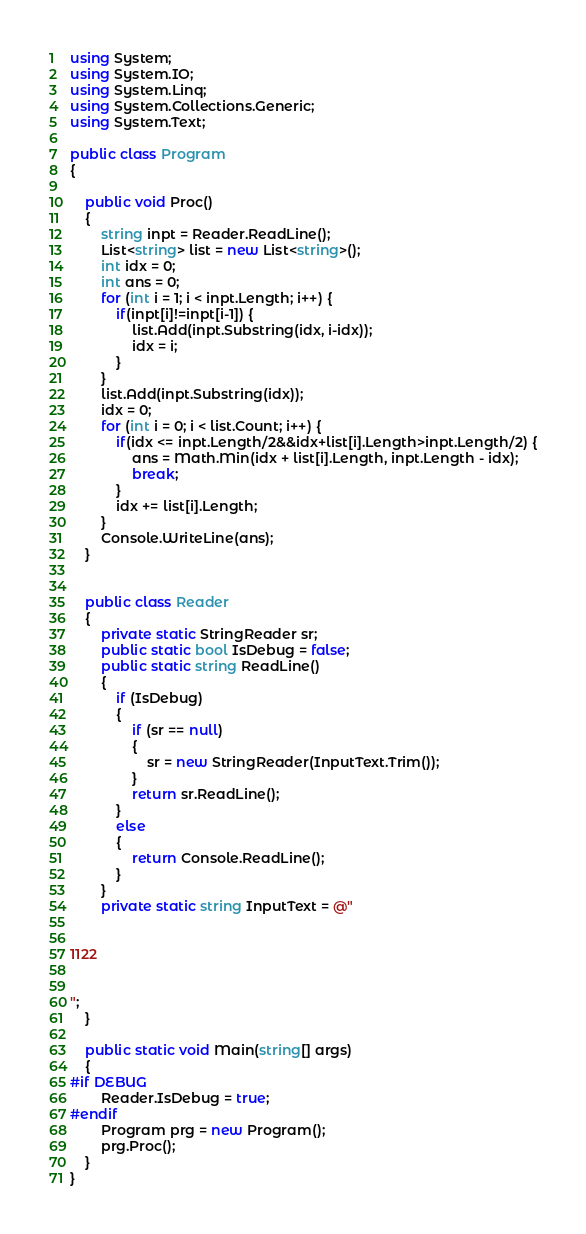<code> <loc_0><loc_0><loc_500><loc_500><_C#_>using System;
using System.IO;
using System.Linq;
using System.Collections.Generic;
using System.Text;

public class Program
{

    public void Proc()
    {
        string inpt = Reader.ReadLine();
        List<string> list = new List<string>();
        int idx = 0;
        int ans = 0;
        for (int i = 1; i < inpt.Length; i++) {
            if(inpt[i]!=inpt[i-1]) {
                list.Add(inpt.Substring(idx, i-idx));
                idx = i;
            }
        }
        list.Add(inpt.Substring(idx));
        idx = 0;
        for (int i = 0; i < list.Count; i++) {
            if(idx <= inpt.Length/2&&idx+list[i].Length>inpt.Length/2) {
                ans = Math.Min(idx + list[i].Length, inpt.Length - idx);
                break;
            }
            idx += list[i].Length;
        }
        Console.WriteLine(ans);
    }


    public class Reader
    {
        private static StringReader sr;
        public static bool IsDebug = false;
        public static string ReadLine()
        {
            if (IsDebug)
            {
                if (sr == null)
                {
                    sr = new StringReader(InputText.Trim());
                }
                return sr.ReadLine();
            }
            else
            {
                return Console.ReadLine();
            }
        }
        private static string InputText = @"


1122


";
    }

    public static void Main(string[] args)
    {
#if DEBUG
        Reader.IsDebug = true;
#endif
        Program prg = new Program();
        prg.Proc();
    }
}
</code> 